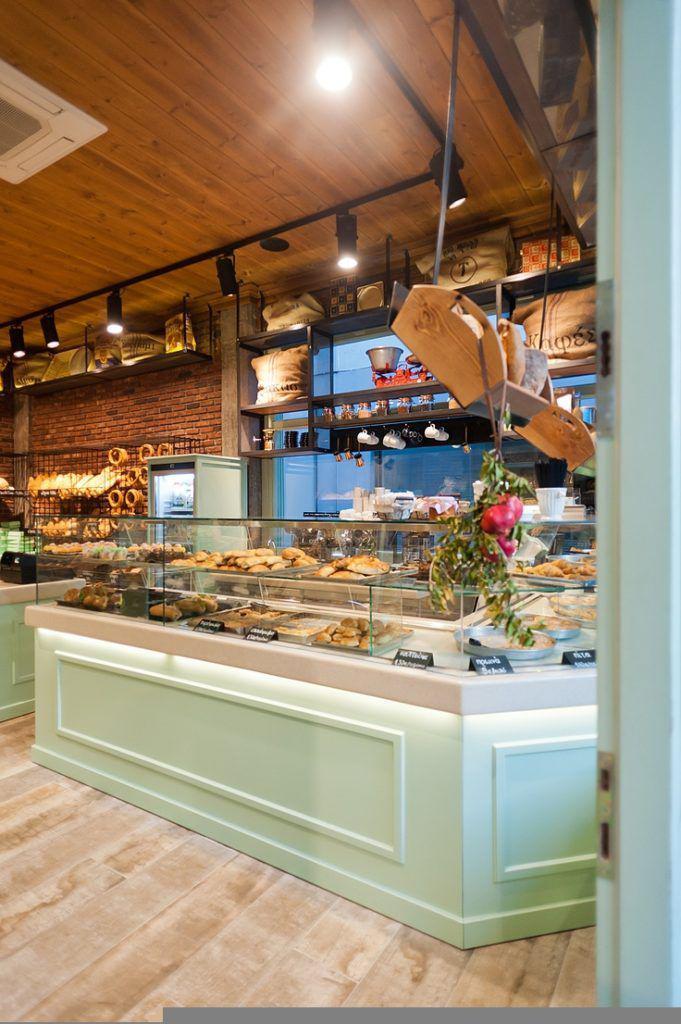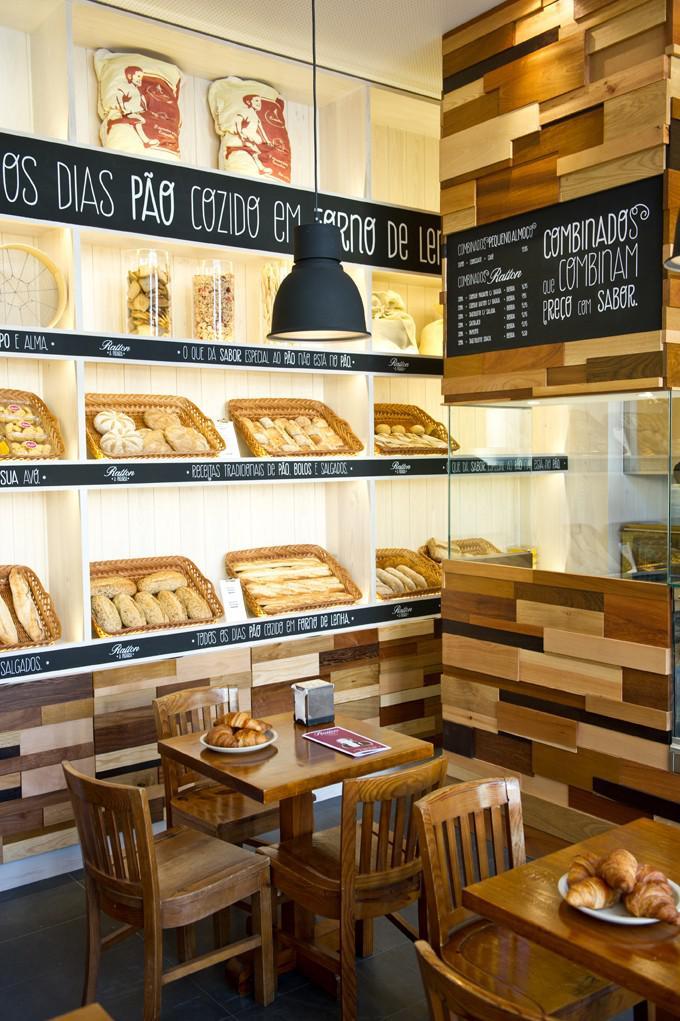The first image is the image on the left, the second image is the image on the right. Examine the images to the left and right. Is the description "Right image shows a bakery with pale green display cases and black track lighting suspended from a wood plank ceiling." accurate? Answer yes or no. No. The first image is the image on the left, the second image is the image on the right. Analyze the images presented: Is the assertion "There is at least one square table with chairs inside a bakery." valid? Answer yes or no. Yes. 